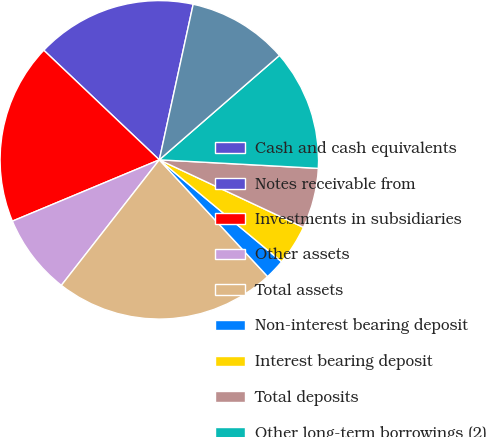<chart> <loc_0><loc_0><loc_500><loc_500><pie_chart><fcel>Cash and cash equivalents<fcel>Notes receivable from<fcel>Investments in subsidiaries<fcel>Other assets<fcel>Total assets<fcel>Non-interest bearing deposit<fcel>Interest bearing deposit<fcel>Total deposits<fcel>Other long-term borrowings (2)<fcel>Accrued expenses and other<nl><fcel>0.0%<fcel>16.33%<fcel>18.37%<fcel>8.16%<fcel>22.45%<fcel>2.04%<fcel>4.08%<fcel>6.12%<fcel>12.24%<fcel>10.2%<nl></chart> 